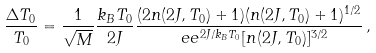Convert formula to latex. <formula><loc_0><loc_0><loc_500><loc_500>\frac { \Delta T _ { 0 } } { T _ { 0 } } = \frac { 1 } { \sqrt { M } } \frac { k _ { B } T _ { 0 } } { 2 J } \frac { ( 2 n ( 2 J , T _ { 0 } ) + 1 ) ( n ( 2 J , T _ { 0 } ) + 1 ) ^ { 1 / 2 } } { \ e e ^ { 2 J / k _ { B } T _ { 0 } } [ n ( 2 J , T _ { 0 } ) ] ^ { 3 / 2 } } \, ,</formula> 